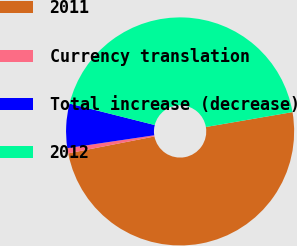Convert chart to OTSL. <chart><loc_0><loc_0><loc_500><loc_500><pie_chart><fcel>2011<fcel>Currency translation<fcel>Total increase (decrease)<fcel>2012<nl><fcel>49.63%<fcel>0.74%<fcel>6.27%<fcel>43.36%<nl></chart> 